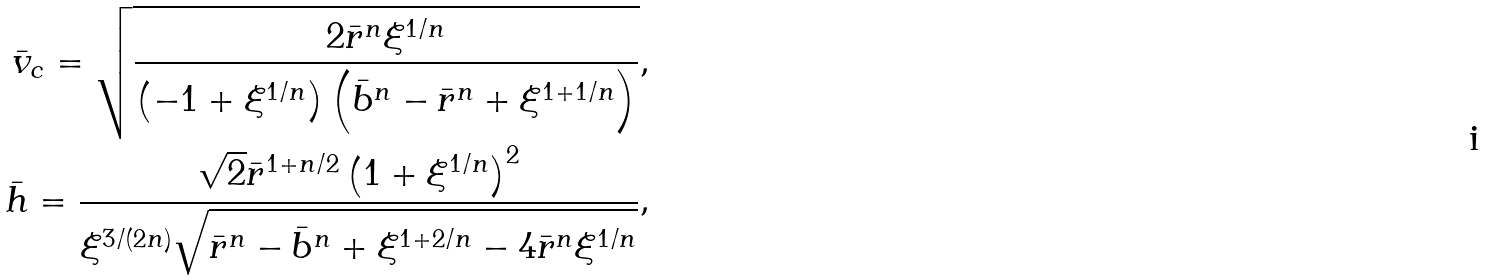<formula> <loc_0><loc_0><loc_500><loc_500>\bar { v } _ { c } = \sqrt { \frac { 2 \bar { r } ^ { n } \xi ^ { 1 / n } } { \left ( - 1 + \xi ^ { 1 / n } \right ) \left ( \bar { b } ^ { n } - \bar { r } ^ { n } + \xi ^ { 1 + 1 / n } \right ) } } , \\ \bar { h } = \frac { \sqrt { 2 } \bar { r } ^ { 1 + n / 2 } \left ( 1 + \xi ^ { 1 / n } \right ) ^ { 2 } } { \xi ^ { 3 / ( 2 n ) } \sqrt { \bar { r } ^ { n } - \bar { b } ^ { n } + \xi ^ { 1 + 2 / n } - 4 \bar { r } ^ { n } \xi ^ { 1 / n } } } ,</formula> 